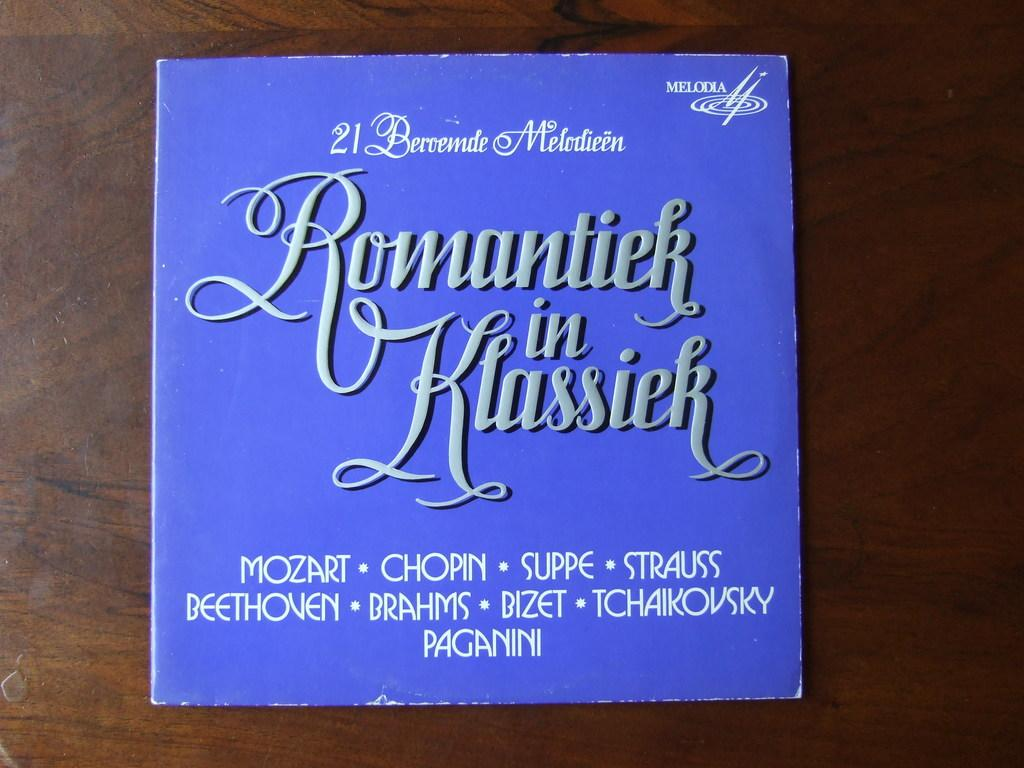<image>
Describe the image concisely. Romantiek in Klassiek record featuring Mozart, Beethoven, and Bizet. 